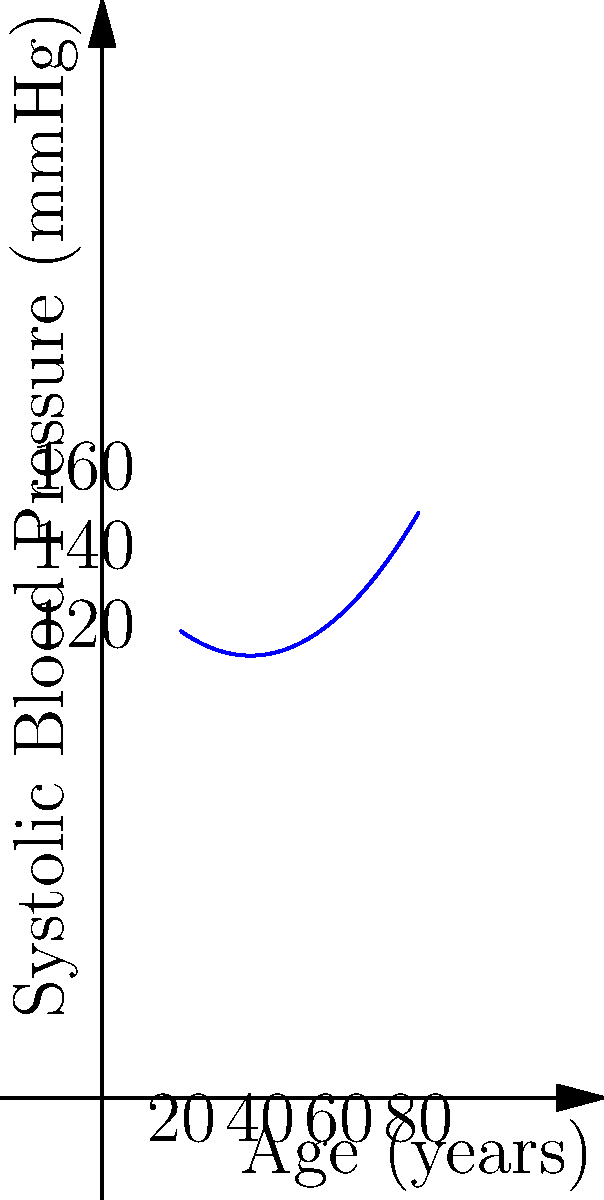As a retired physician reviewing a medical article, you encounter a polynomial regression graph depicting the relationship between age and systolic blood pressure. The graph shows a U-shaped curve. Given that the polynomial equation is of the form $f(x) = ax^2 + bx + c$, where $x$ represents age in years and $f(x)$ represents systolic blood pressure in mmHg, what is the approximate age at which systolic blood pressure reaches its minimum value? To find the age at which systolic blood pressure reaches its minimum value, we need to follow these steps:

1) The general form of the polynomial is $f(x) = ax^2 + bx + c$, where $a > 0$ (since the curve is U-shaped).

2) The minimum point of a parabola occurs at the vertex. For a quadratic function, the x-coordinate of the vertex is given by $x = -\frac{b}{2a}$.

3) From the graph, we can estimate that the minimum point occurs around 40 years of age.

4) To verify this mathematically, we'd need the exact coefficients of the polynomial. However, as medical professionals, we often work with approximations from visual data.

5) The U-shape of the curve indicates that blood pressure tends to decrease in early adulthood and then increase again in later years, which aligns with general medical knowledge about age-related changes in blood pressure.

6) Given the scale of the graph and the shape of the curve, an estimate of 40 years for the minimum point is reasonable and consistent with typical medical observations.
Answer: Approximately 40 years 